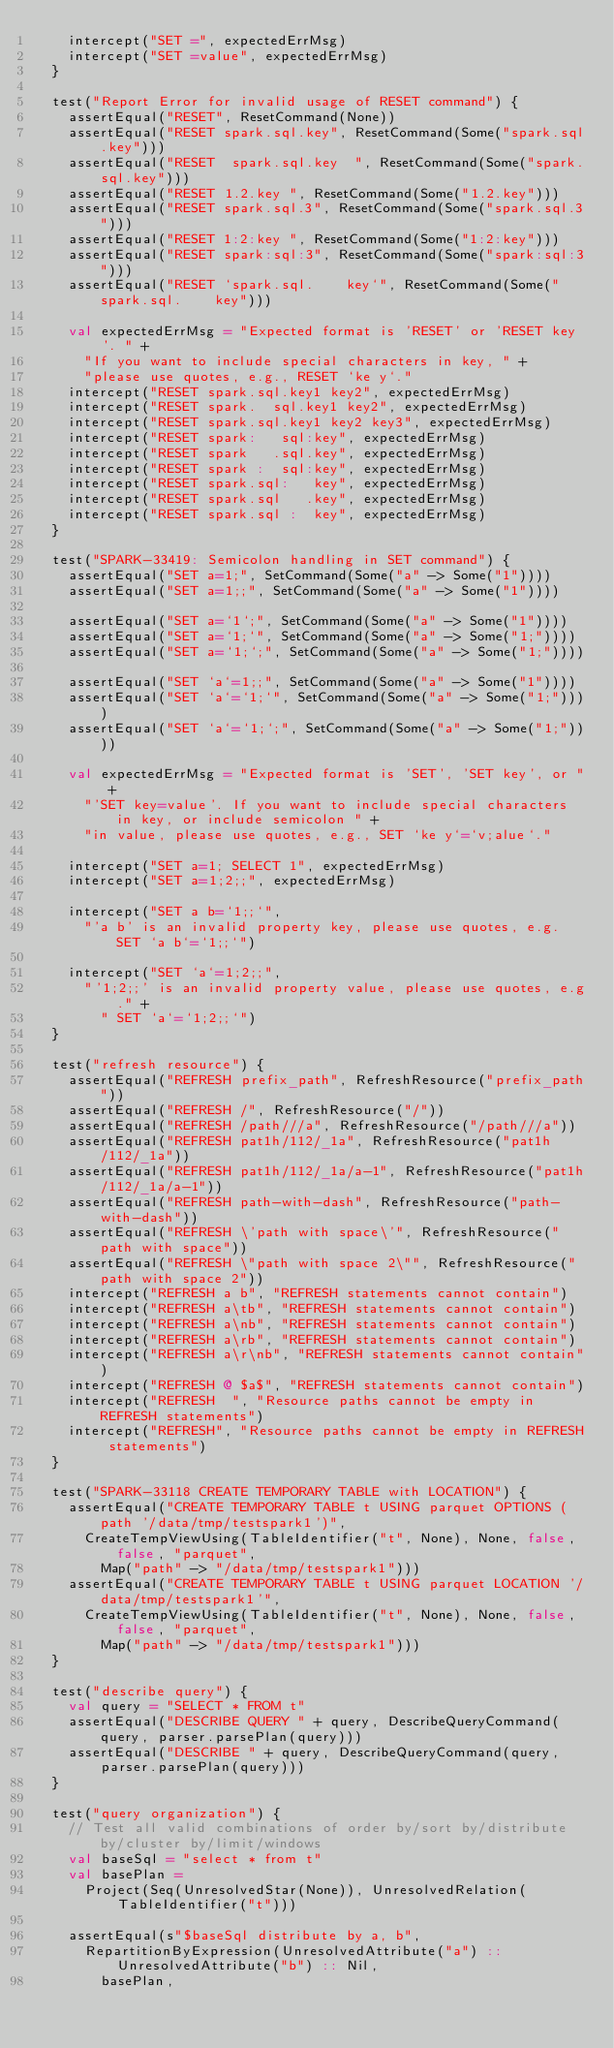<code> <loc_0><loc_0><loc_500><loc_500><_Scala_>    intercept("SET =", expectedErrMsg)
    intercept("SET =value", expectedErrMsg)
  }

  test("Report Error for invalid usage of RESET command") {
    assertEqual("RESET", ResetCommand(None))
    assertEqual("RESET spark.sql.key", ResetCommand(Some("spark.sql.key")))
    assertEqual("RESET  spark.sql.key  ", ResetCommand(Some("spark.sql.key")))
    assertEqual("RESET 1.2.key ", ResetCommand(Some("1.2.key")))
    assertEqual("RESET spark.sql.3", ResetCommand(Some("spark.sql.3")))
    assertEqual("RESET 1:2:key ", ResetCommand(Some("1:2:key")))
    assertEqual("RESET spark:sql:3", ResetCommand(Some("spark:sql:3")))
    assertEqual("RESET `spark.sql.    key`", ResetCommand(Some("spark.sql.    key")))

    val expectedErrMsg = "Expected format is 'RESET' or 'RESET key'. " +
      "If you want to include special characters in key, " +
      "please use quotes, e.g., RESET `ke y`."
    intercept("RESET spark.sql.key1 key2", expectedErrMsg)
    intercept("RESET spark.  sql.key1 key2", expectedErrMsg)
    intercept("RESET spark.sql.key1 key2 key3", expectedErrMsg)
    intercept("RESET spark:   sql:key", expectedErrMsg)
    intercept("RESET spark   .sql.key", expectedErrMsg)
    intercept("RESET spark :  sql:key", expectedErrMsg)
    intercept("RESET spark.sql:   key", expectedErrMsg)
    intercept("RESET spark.sql   .key", expectedErrMsg)
    intercept("RESET spark.sql :  key", expectedErrMsg)
  }

  test("SPARK-33419: Semicolon handling in SET command") {
    assertEqual("SET a=1;", SetCommand(Some("a" -> Some("1"))))
    assertEqual("SET a=1;;", SetCommand(Some("a" -> Some("1"))))

    assertEqual("SET a=`1`;", SetCommand(Some("a" -> Some("1"))))
    assertEqual("SET a=`1;`", SetCommand(Some("a" -> Some("1;"))))
    assertEqual("SET a=`1;`;", SetCommand(Some("a" -> Some("1;"))))

    assertEqual("SET `a`=1;;", SetCommand(Some("a" -> Some("1"))))
    assertEqual("SET `a`=`1;`", SetCommand(Some("a" -> Some("1;"))))
    assertEqual("SET `a`=`1;`;", SetCommand(Some("a" -> Some("1;"))))

    val expectedErrMsg = "Expected format is 'SET', 'SET key', or " +
      "'SET key=value'. If you want to include special characters in key, or include semicolon " +
      "in value, please use quotes, e.g., SET `ke y`=`v;alue`."

    intercept("SET a=1; SELECT 1", expectedErrMsg)
    intercept("SET a=1;2;;", expectedErrMsg)

    intercept("SET a b=`1;;`",
      "'a b' is an invalid property key, please use quotes, e.g. SET `a b`=`1;;`")

    intercept("SET `a`=1;2;;",
      "'1;2;;' is an invalid property value, please use quotes, e.g." +
        " SET `a`=`1;2;;`")
  }

  test("refresh resource") {
    assertEqual("REFRESH prefix_path", RefreshResource("prefix_path"))
    assertEqual("REFRESH /", RefreshResource("/"))
    assertEqual("REFRESH /path///a", RefreshResource("/path///a"))
    assertEqual("REFRESH pat1h/112/_1a", RefreshResource("pat1h/112/_1a"))
    assertEqual("REFRESH pat1h/112/_1a/a-1", RefreshResource("pat1h/112/_1a/a-1"))
    assertEqual("REFRESH path-with-dash", RefreshResource("path-with-dash"))
    assertEqual("REFRESH \'path with space\'", RefreshResource("path with space"))
    assertEqual("REFRESH \"path with space 2\"", RefreshResource("path with space 2"))
    intercept("REFRESH a b", "REFRESH statements cannot contain")
    intercept("REFRESH a\tb", "REFRESH statements cannot contain")
    intercept("REFRESH a\nb", "REFRESH statements cannot contain")
    intercept("REFRESH a\rb", "REFRESH statements cannot contain")
    intercept("REFRESH a\r\nb", "REFRESH statements cannot contain")
    intercept("REFRESH @ $a$", "REFRESH statements cannot contain")
    intercept("REFRESH  ", "Resource paths cannot be empty in REFRESH statements")
    intercept("REFRESH", "Resource paths cannot be empty in REFRESH statements")
  }

  test("SPARK-33118 CREATE TEMPORARY TABLE with LOCATION") {
    assertEqual("CREATE TEMPORARY TABLE t USING parquet OPTIONS (path '/data/tmp/testspark1')",
      CreateTempViewUsing(TableIdentifier("t", None), None, false, false, "parquet",
        Map("path" -> "/data/tmp/testspark1")))
    assertEqual("CREATE TEMPORARY TABLE t USING parquet LOCATION '/data/tmp/testspark1'",
      CreateTempViewUsing(TableIdentifier("t", None), None, false, false, "parquet",
        Map("path" -> "/data/tmp/testspark1")))
  }

  test("describe query") {
    val query = "SELECT * FROM t"
    assertEqual("DESCRIBE QUERY " + query, DescribeQueryCommand(query, parser.parsePlan(query)))
    assertEqual("DESCRIBE " + query, DescribeQueryCommand(query, parser.parsePlan(query)))
  }

  test("query organization") {
    // Test all valid combinations of order by/sort by/distribute by/cluster by/limit/windows
    val baseSql = "select * from t"
    val basePlan =
      Project(Seq(UnresolvedStar(None)), UnresolvedRelation(TableIdentifier("t")))

    assertEqual(s"$baseSql distribute by a, b",
      RepartitionByExpression(UnresolvedAttribute("a") :: UnresolvedAttribute("b") :: Nil,
        basePlan,</code> 